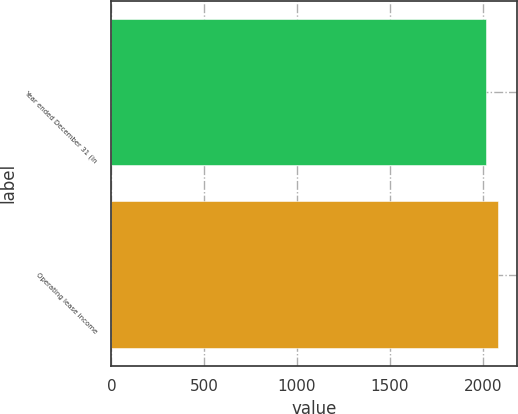<chart> <loc_0><loc_0><loc_500><loc_500><bar_chart><fcel>Year ended December 31 (in<fcel>Operating lease income<nl><fcel>2015<fcel>2081<nl></chart> 